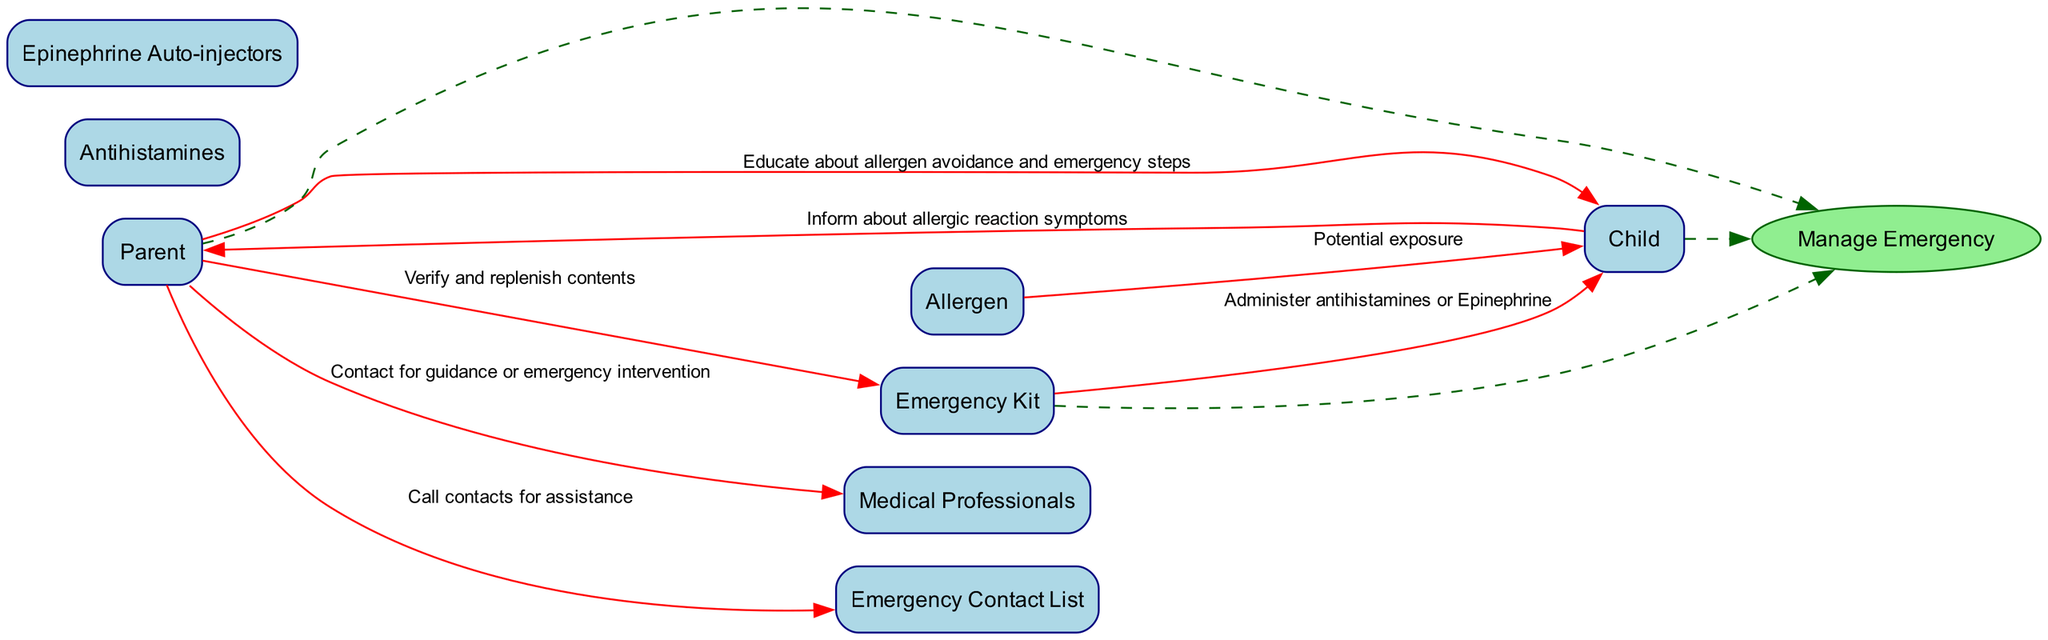What is the number of entities in the diagram? The diagram lists six entities: Parent, Child, Emergency Kit, Allergen, Medical Professionals, and Emergency Contact List. Counting them gives a total of six entities.
Answer: 6 Which item is responsible for administering medications? The flow indicates that the Emergency Kit provides antihistamines or Epinephrine to the Child during an allergic reaction, making it responsible for administering medications.
Answer: Emergency Kit What action does the Parent take regarding the Emergency Kit? According to the diagram, the Parent verifies and replenishes the contents of the Emergency Kit. This action shows responsibility for ensuring the kit is ready for emergencies.
Answer: Verify and replenish contents How does the Child inform the Parent about allergic reaction symptoms? The diagram shows a direct data flow where the Child informs the Parent about symptoms, indicating that communication flows from the Child to the Parent for this particular action.
Answer: Inform What is the relationship between the Parent and the Medical Professionals? The diagram specifies that the Parent contacts Medical Professionals for guidance or emergency intervention, illustrating a direct communication and reliance upon healthcare providers in emergencies.
Answer: Contact What is the outcome of potential exposure to Allergen for the Child? The diagram shows that the potential exposure to an Allergen leads to allergic reaction symptoms experienced by the Child, indicating a direct consequence of allergen exposure.
Answer: Potential exposure Which role is depicted with the process 'Manage Emergency'? The process 'Manage Emergency' is closely associated with the Parent, as the diagram indicates that the Parent takes steps to handle an allergic reaction, including administering medications and contacting professionals.
Answer: Parent How many data flows are present in the diagram? By counting the arrows connecting the entities and showing the flow of information, we find that there are seven distinct data flows illustrated in the diagram.
Answer: 7 What role has a dashed connection to the 'Manage Emergency' process? The Parent, Child, and Emergency Kit all have dashed connections to the 'Manage Emergency' process, indicating their involvement in emergency management. Specifically, the Parent is initiating this management process.
Answer: Parent 